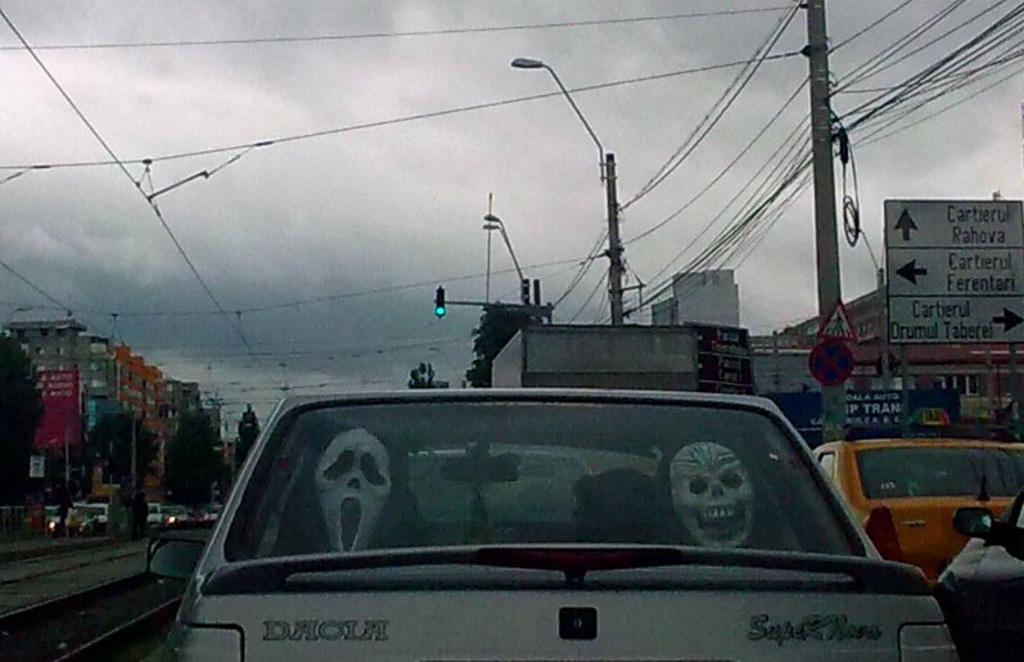What type of car is this?
Give a very brief answer. Dacla. 